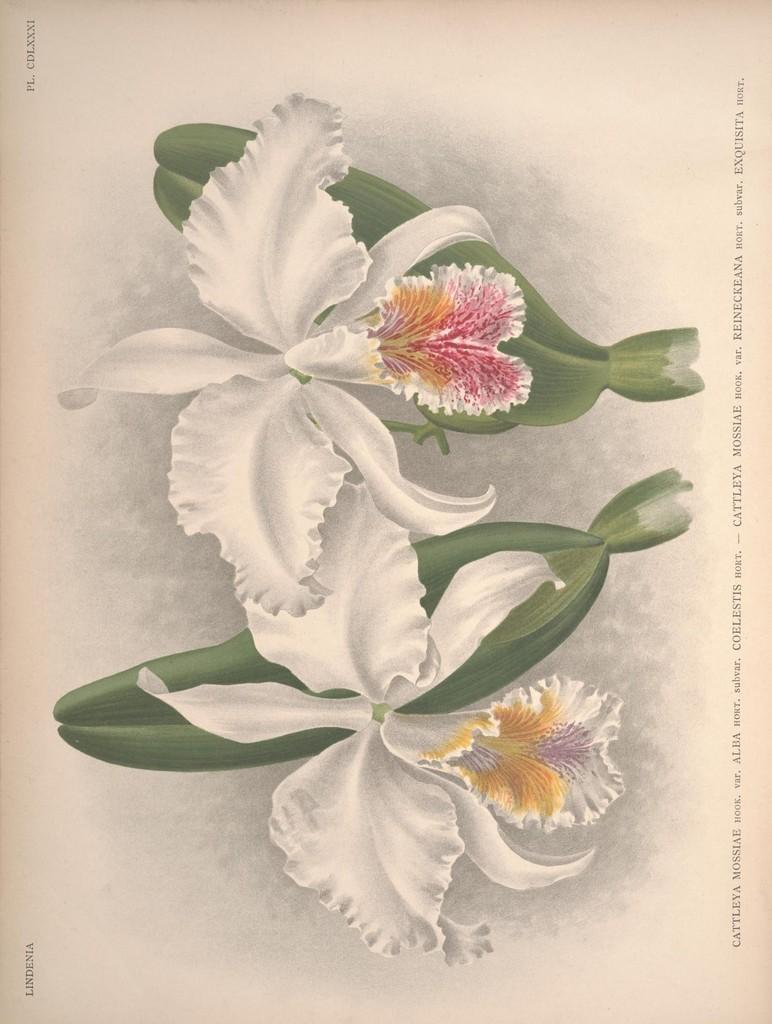How would you summarize this image in a sentence or two? This is a painting and here we can see flowers and there is a text. 